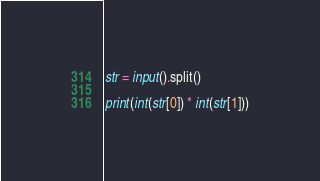<code> <loc_0><loc_0><loc_500><loc_500><_Python_>str = input().split()

print(int(str[0]) * int(str[1]))</code> 